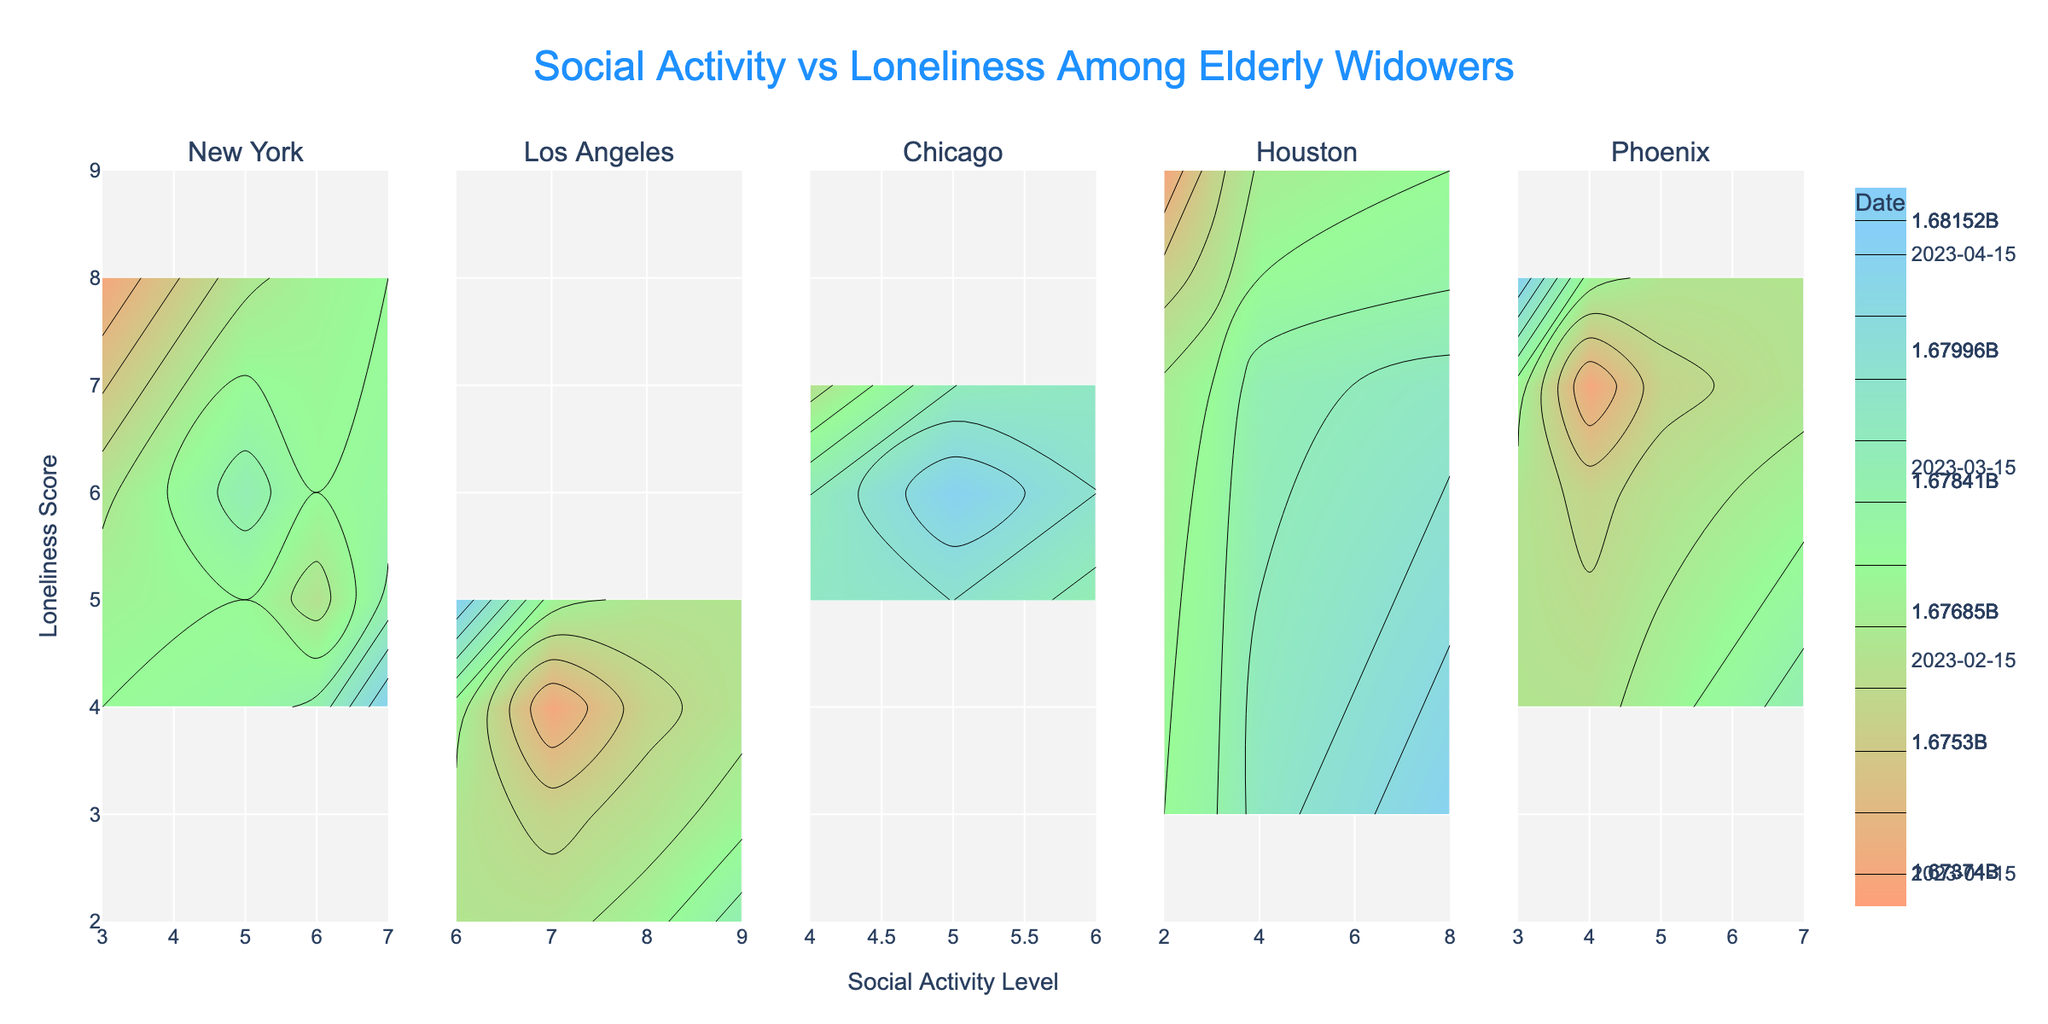How many subplots are there in the figure? There are five locations listed in the dataset (New York, Los Angeles, Chicago, Houston, Phoenix). Each location has its own subplot. Therefore, there are five subplots in the figure.
Answer: 5 What is the title of the figure? The title of the figure is clearly stated at the top and reads, "Social Activity vs Loneliness Among Elderly Widowers".
Answer: Social Activity vs Loneliness Among Elderly Widowers Which location has the highest Social Activity Level at any point in time? By examining the contours in each subplot, we can identify the maximum Social Activity Level values. Los Angeles reaches the maximum Social Activity Level of 9 on 2023-03-15.
Answer: Los Angeles Which location exhibits the highest Loneliness Score? By looking at the y-axis in each subplot, Houston has the highest Loneliness Score of 9 recorded on 2023-01-15 and 2023-02-15.
Answer: Houston During which month did Phoenix experience the lowest Loneliness Score? By examining the color bar and the positions on the y-axis within Phoenix’s subplot, the lowest Loneliness Score for Phoenix, which is 4, occurred in March and April (dates: 2023-03-15 and 2023-04-15).
Answer: March and April Can you compare the trends in Los Angeles and Chicago’s Social Activity Levels over time? The contours in Los Angeles show an increasing trend in Social Activity Levels over time, peaking at 9. In contrast, Chicago shows more stable levels, fluctuating between 4 and 6.
Answer: Increasing (Los Angeles), Stable/Fluctuating (Chicago) In which subplot does the Loneliness Score decrease most significantly from January to April? By examining the number of contours that indicate a decrease in Loneliness Score from January to April, Los Angeles shows the most significant decrease in Loneliness Score from 4 to 2.
Answer: Los Angeles What does the color scale represent in the figure? The color scale in the contours represents the date. Different colors correspond to different dates, helping to visualize how Social Activity Levels and Loneliness Scores change over time.
Answer: Date 